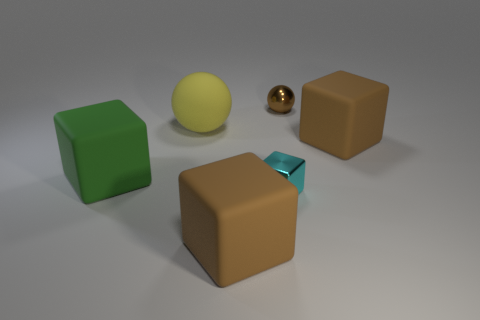What color is the shiny thing that is the same shape as the large yellow rubber object?
Your answer should be very brief. Brown. How big is the thing that is both behind the green matte block and in front of the yellow matte thing?
Keep it short and to the point. Large. There is a small shiny thing that is in front of the block on the right side of the small ball; how many cyan metal things are on the right side of it?
Provide a short and direct response. 0. What number of large things are cubes or purple metal things?
Ensure brevity in your answer.  3. Is the material of the object in front of the small cube the same as the cyan block?
Keep it short and to the point. No. The large brown thing that is right of the brown object that is left of the ball that is to the right of the yellow matte thing is made of what material?
Provide a succinct answer. Rubber. Is there any other thing that has the same size as the cyan cube?
Your answer should be very brief. Yes. How many metal things are either blue cubes or brown blocks?
Ensure brevity in your answer.  0. Are any small yellow matte things visible?
Ensure brevity in your answer.  No. What is the color of the tiny metallic thing in front of the brown object behind the matte sphere?
Your response must be concise. Cyan. 